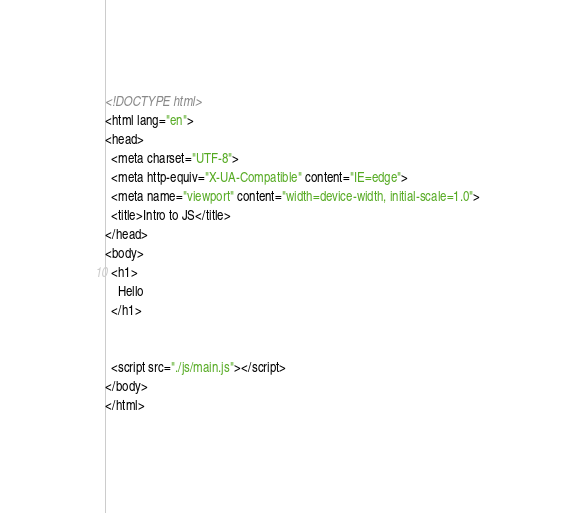Convert code to text. <code><loc_0><loc_0><loc_500><loc_500><_HTML_><!DOCTYPE html>
<html lang="en">
<head>
  <meta charset="UTF-8">
  <meta http-equiv="X-UA-Compatible" content="IE=edge">
  <meta name="viewport" content="width=device-width, initial-scale=1.0">
  <title>Intro to JS</title>
</head>
<body>
  <h1>
    Hello
  </h1>


  <script src="./js/main.js"></script>
</body>
</html></code> 